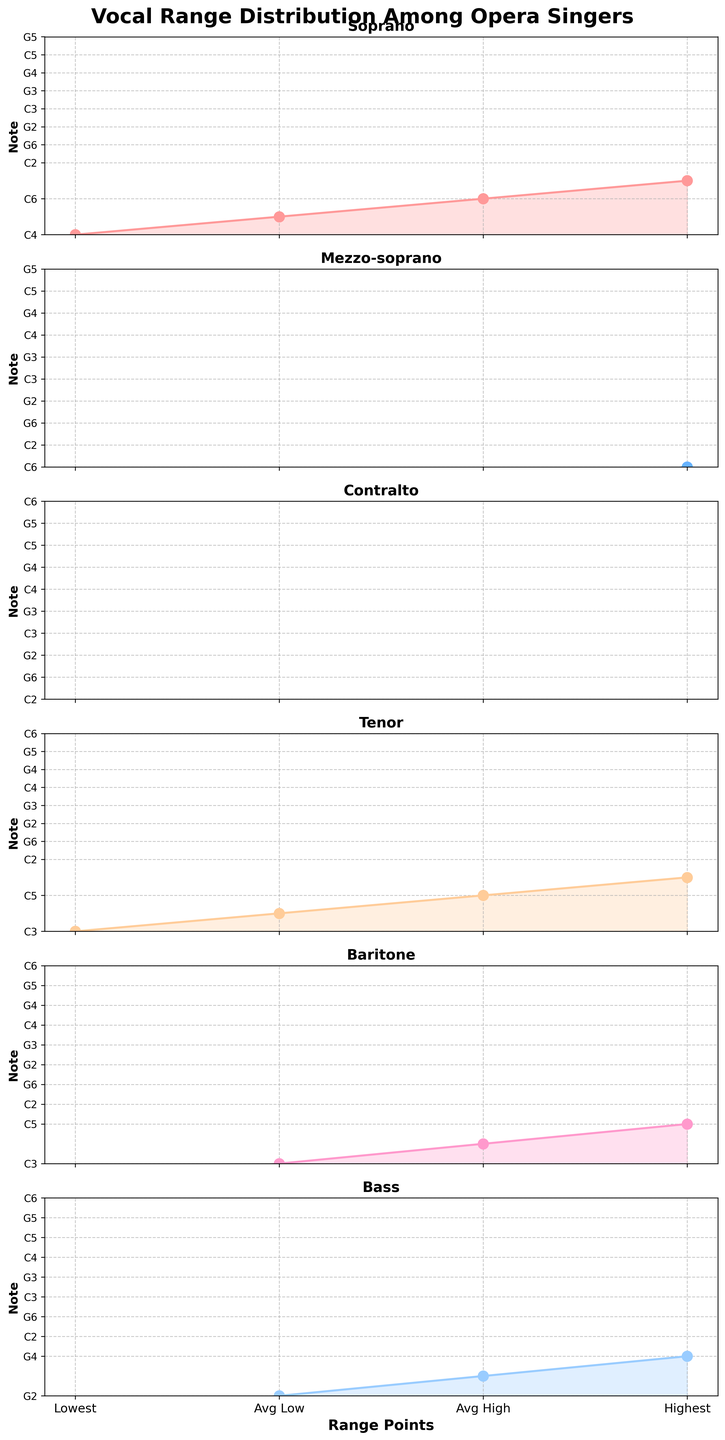What is the title of the figure? The title is usually displayed at the top of the figure and summarizes the content. In this case, it is given as 'Vocal Range Distribution Among Opera Singers'.
Answer: Vocal Range Distribution Among Opera Singers Which voice type has the lowest note, and what is the note? To determine this, observe the 'Lowest Note' displayed on each subplot. Bass has 'E2', which is the lowest among the voice types.
Answer: Bass (E2) What are the lowest and highest notes for a Soprano? Identify the Soprano subplot and check the y-axis labels for 'Lowest Note' and 'Highest Note'. The lowest note is 'C4' and the highest note is 'F6'.
Answer: C4, F6 Which voice type has the narrowest vocal range? Calculate the range for each voice type by comparing their 'Lowest Note' and 'Highest Note', then identify the smallest difference. Contralto ranges from 'F3' to 'A5', a difference of 2 octaves and a third (smallest range).
Answer: Contralto What's the average low note of a Baritone? Look at the Baritone subplot and observe the data point for 'Average Low'. The note is 'C3'.
Answer: C3 How does the average high note of a Tenor compare to that of a Mezzo-soprano? Check the 'Average High' notes for both Tenor and Mezzo-soprano. Tenor's 'Average High' is 'C5', and Mezzo-soprano's 'Average High' is 'A5'.
Answer: Tenor (C5), Mezzo-soprano (A5) Which voice type has the highest range span between 'Lowest Note' and 'Highest Note'? Calculate the range span for each voice type by noting the 'Lowest Note' and 'Highest Note'. Soprano spans from 'C4' to 'F6', covering 2 octaves and a sixth (widest range).
Answer: Soprano What is the average high note for Contralto and Tenor combined? Take the average of 'Average High' notes of Contralto ('F5') and Tenor ('C5'): Converting to semitones (F5: 65, C5: 60), average is (65+60)/2=62.5, converting back gives a note between 'C#5' and 'D5'.
Answer: Between C#5 and D5 